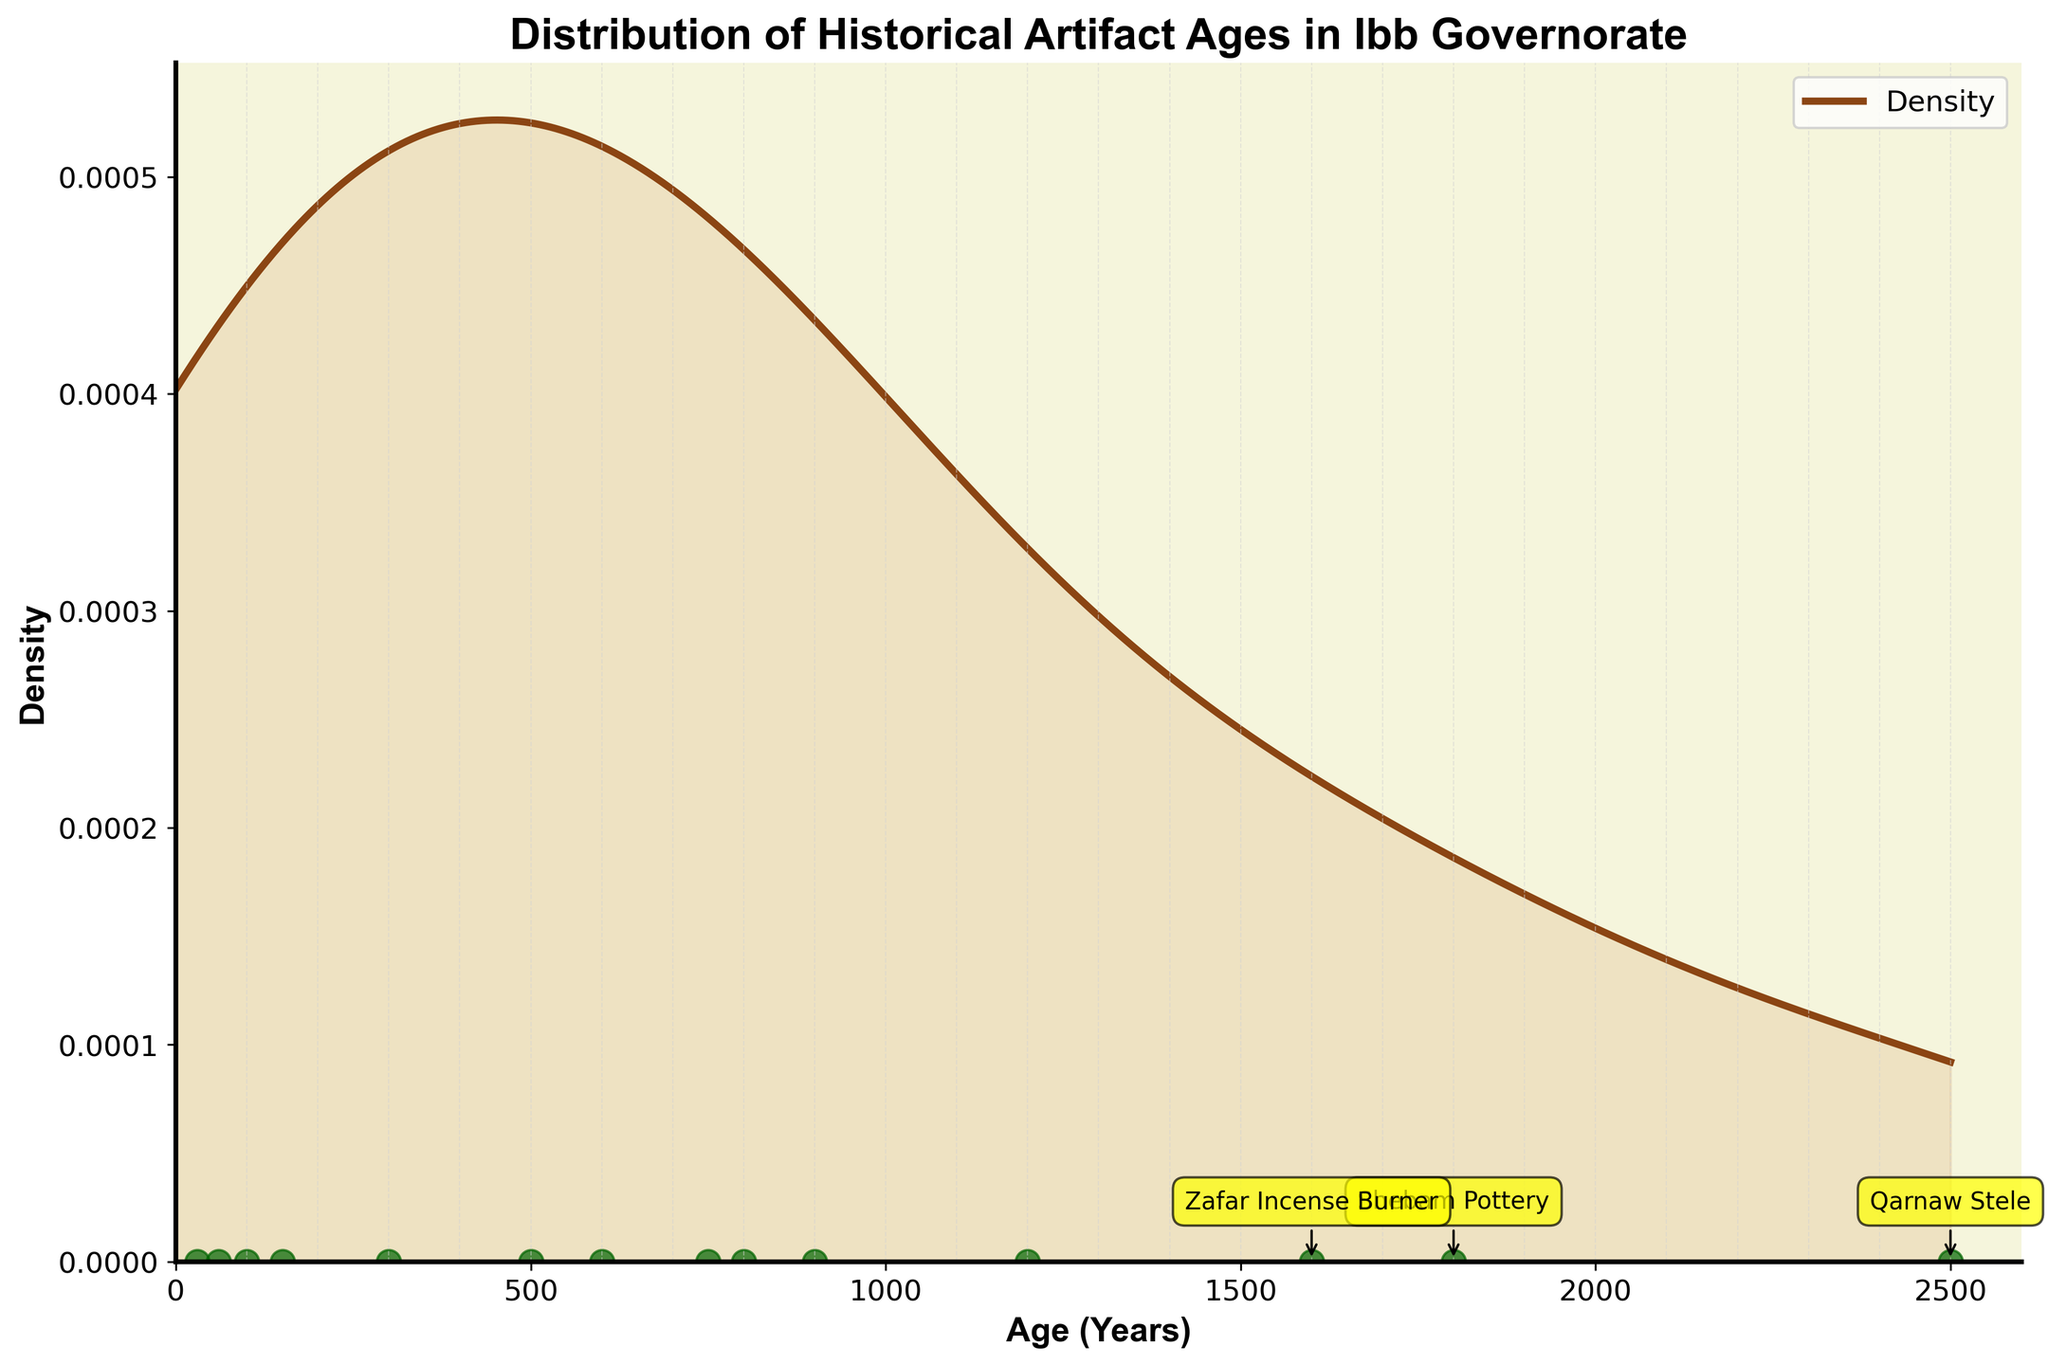How many distinct artifact ages are displayed in the plot? There are distinct scatter points representing the artifact ages. By counting each scatter point, we find there are 14 ages shown in the plot.
Answer: 14 What color is used to fill the area under the density curve? The area under the density curve is filled with a transparent light brown color. This appears as a light tan shade in the plot.
Answer: Light tan What is the title of the plot? The title of the plot is prominently displayed at the top center. It reads "Distribution of Historical Artifact Ages in Ibb Governorate."
Answer: Distribution of Historical Artifact Ages in Ibb Governorate Which artifact has the highest age and is annotated in the plot? The artifact with the highest age is labeled with its annotation. It is "Qarnaw Stele," with an age of 2500 years, located furthest to the right.
Answer: Qarnaw Stele What is the range of the ages of the artifacts shown in the plot? The ages of the artifacts span from 30 years for the youngest artifact (Unification Monument) to 2500 years for the oldest artifact (Qarnaw Stele).
Answer: 30 to 2500 years How many artifacts are more than 1000 years old according to the plot? By examining the scatter points and their ages annotated, artifacts above 1000 years include Qarnaw Stele, Shebam Pottery, Zafar Incense Burner, and Al-Janad Mosque Inscription. There are 4 such artifacts.
Answer: 4 Which artifact is closest to 1000 years old? The artifact age nearest to 1000 years should be identified. By looking at the scatter points, "Ba'dan Castle Coins" is closest at an age of 900 years.
Answer: Ba'dan Castle Coins What is the approximate maximum density value on the plot? Checking the peak of the density curve on the y-axis, the maximum density value appears to be just around 0.0035.
Answer: 0.0035 Which period contributed the least to the density plot, considering the distribution's shape? Noticing the density curve's shape, the period contributing the least is the modern era with ages close to 0, particularly between 0 and 100 years, where the curve remains low.
Answer: Modern era Why are there vertical dashed lines in the background and what do they signify? The plot includes vertical dashed lines for every 100 years from 0 to 2600. They are faintly visible and seem to be used as a subtle alignment aid to help read the x-axis values more easily.
Answer: They serve as guides for the x-axis values 